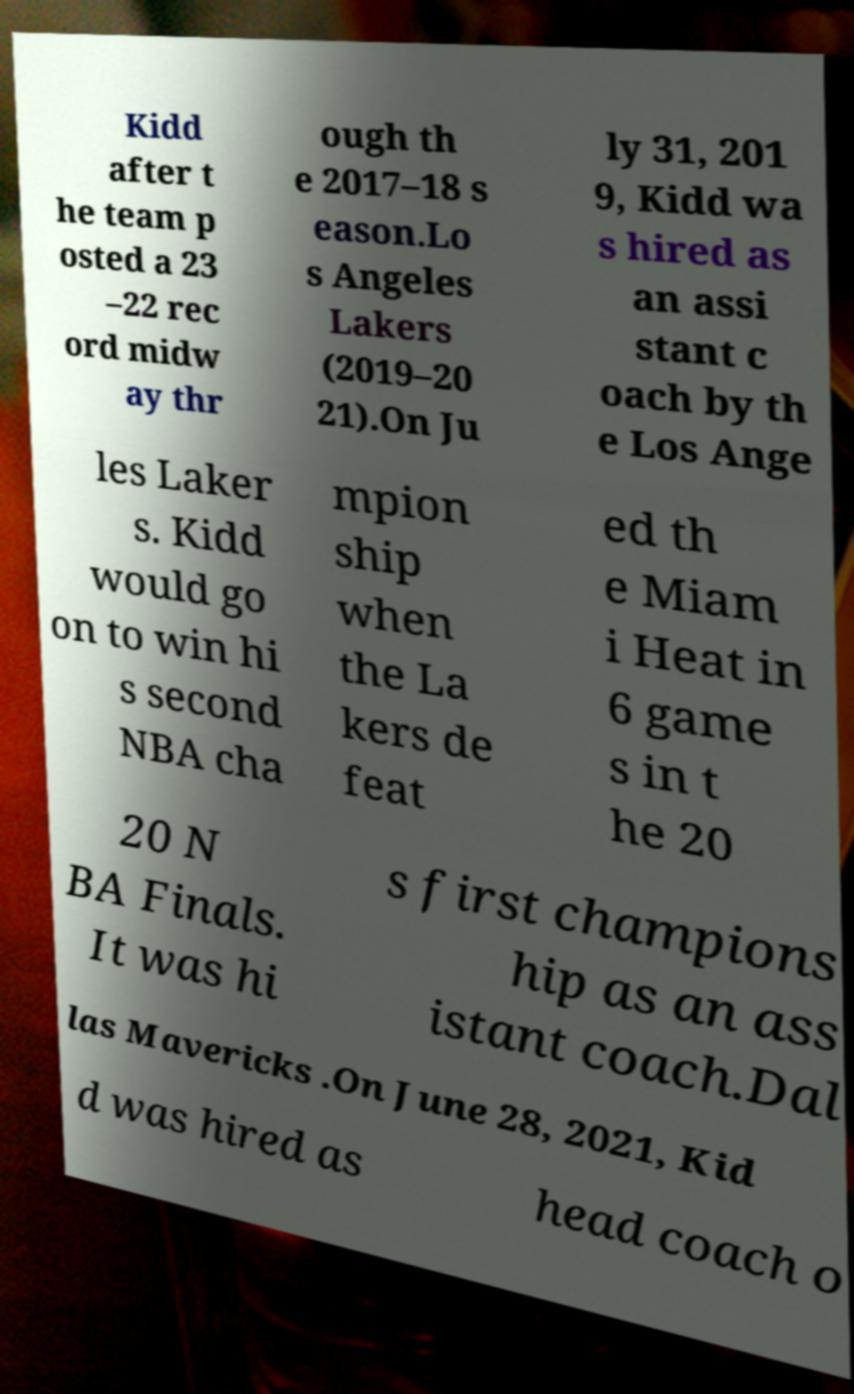I need the written content from this picture converted into text. Can you do that? Kidd after t he team p osted a 23 –22 rec ord midw ay thr ough th e 2017–18 s eason.Lo s Angeles Lakers (2019–20 21).On Ju ly 31, 201 9, Kidd wa s hired as an assi stant c oach by th e Los Ange les Laker s. Kidd would go on to win hi s second NBA cha mpion ship when the La kers de feat ed th e Miam i Heat in 6 game s in t he 20 20 N BA Finals. It was hi s first champions hip as an ass istant coach.Dal las Mavericks .On June 28, 2021, Kid d was hired as head coach o 